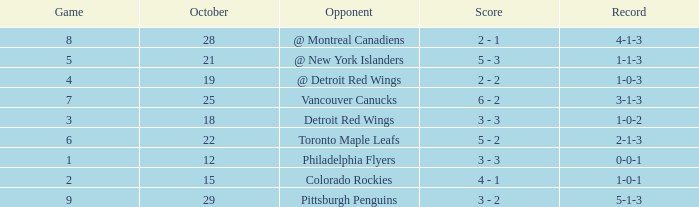Name the least game for record of 1-0-2 3.0. 